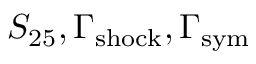Convert formula to latex. <formula><loc_0><loc_0><loc_500><loc_500>S _ { 2 5 } , \Gamma _ { s h o c k } , \Gamma _ { s y m }</formula> 